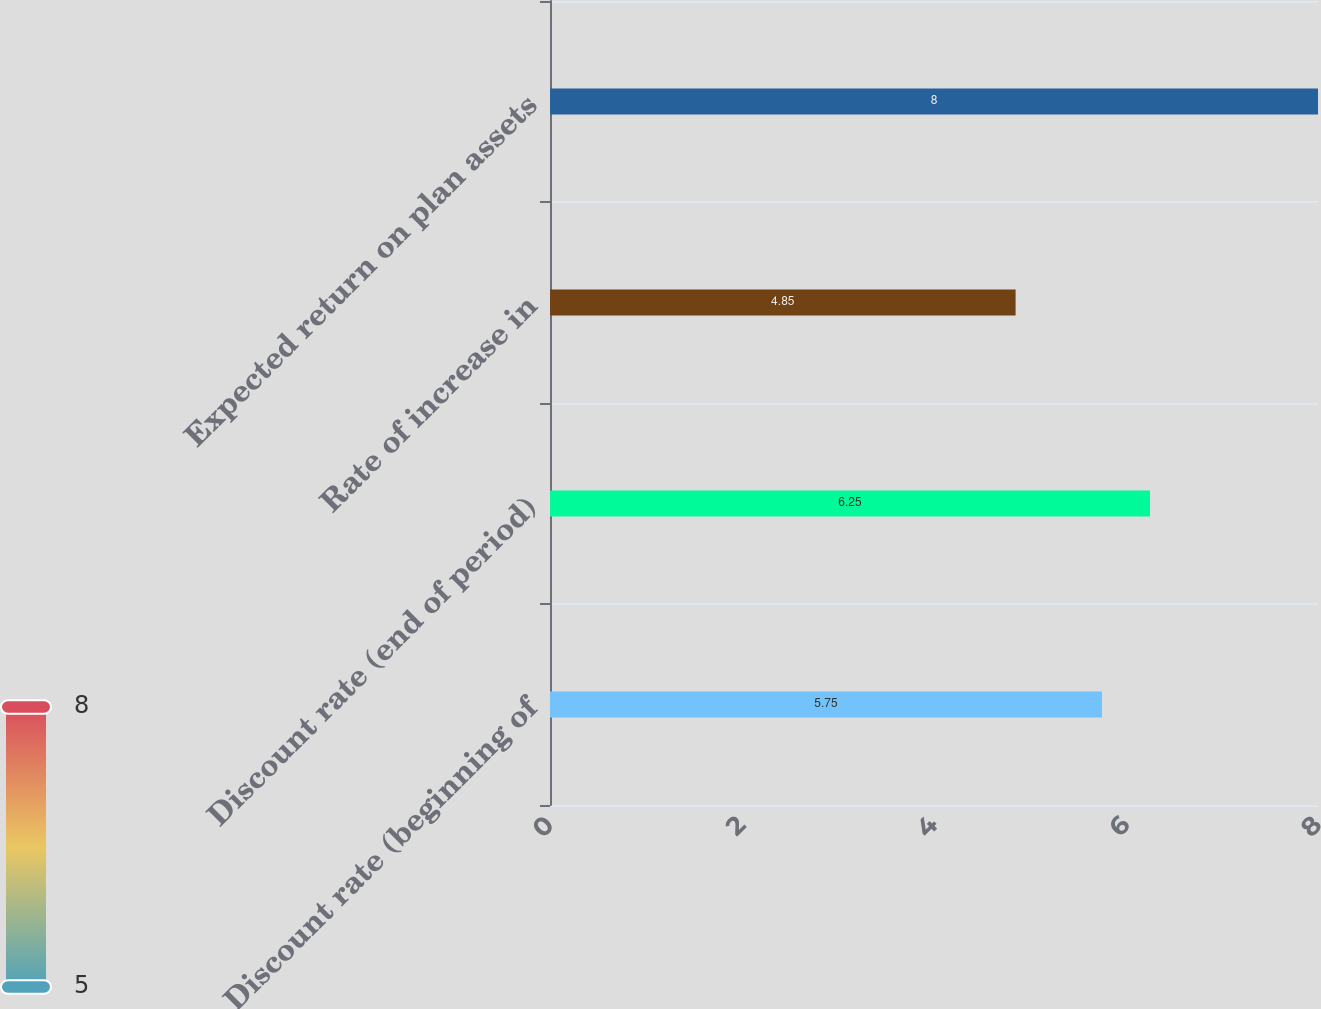Convert chart. <chart><loc_0><loc_0><loc_500><loc_500><bar_chart><fcel>Discount rate (beginning of<fcel>Discount rate (end of period)<fcel>Rate of increase in<fcel>Expected return on plan assets<nl><fcel>5.75<fcel>6.25<fcel>4.85<fcel>8<nl></chart> 